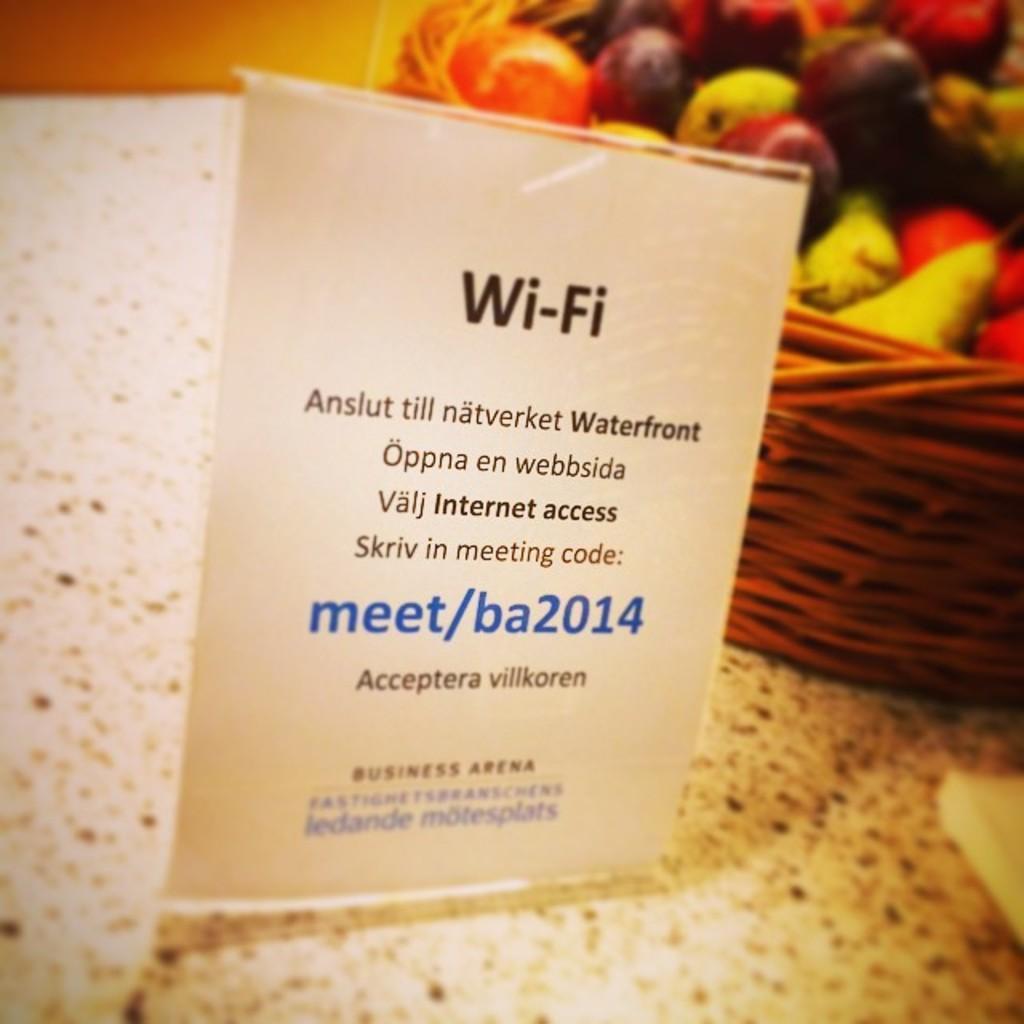In one or two sentences, can you explain what this image depicts? Here I can see a tag with some text and numbers. On the right side there is a basket which consists of some fruits 